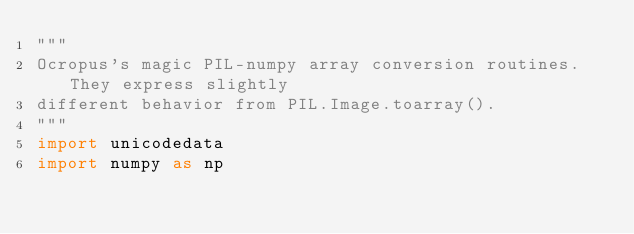<code> <loc_0><loc_0><loc_500><loc_500><_Python_>"""
Ocropus's magic PIL-numpy array conversion routines. They express slightly
different behavior from PIL.Image.toarray().
"""
import unicodedata
import numpy as np
</code> 